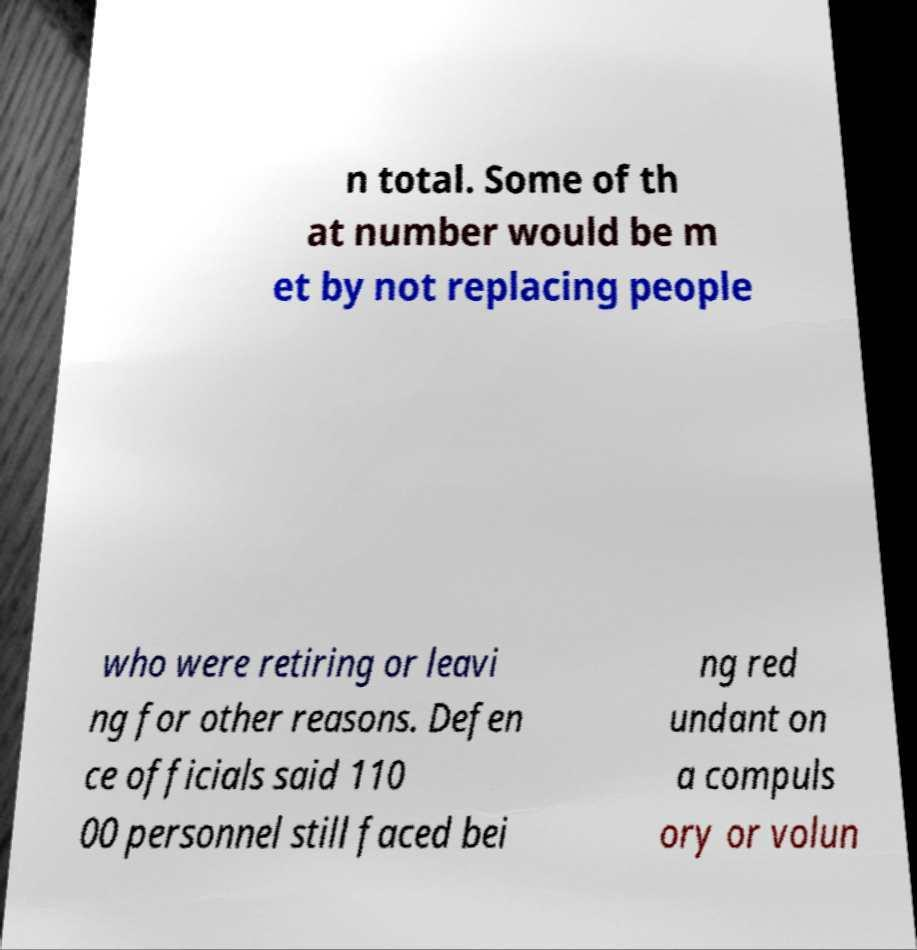For documentation purposes, I need the text within this image transcribed. Could you provide that? n total. Some of th at number would be m et by not replacing people who were retiring or leavi ng for other reasons. Defen ce officials said 110 00 personnel still faced bei ng red undant on a compuls ory or volun 